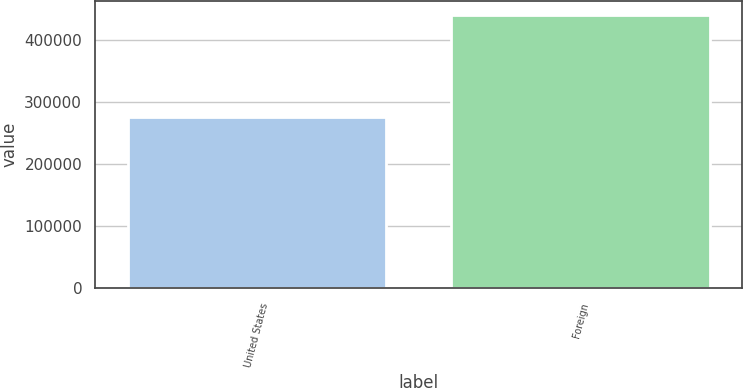<chart> <loc_0><loc_0><loc_500><loc_500><bar_chart><fcel>United States<fcel>Foreign<nl><fcel>276714<fcel>441881<nl></chart> 